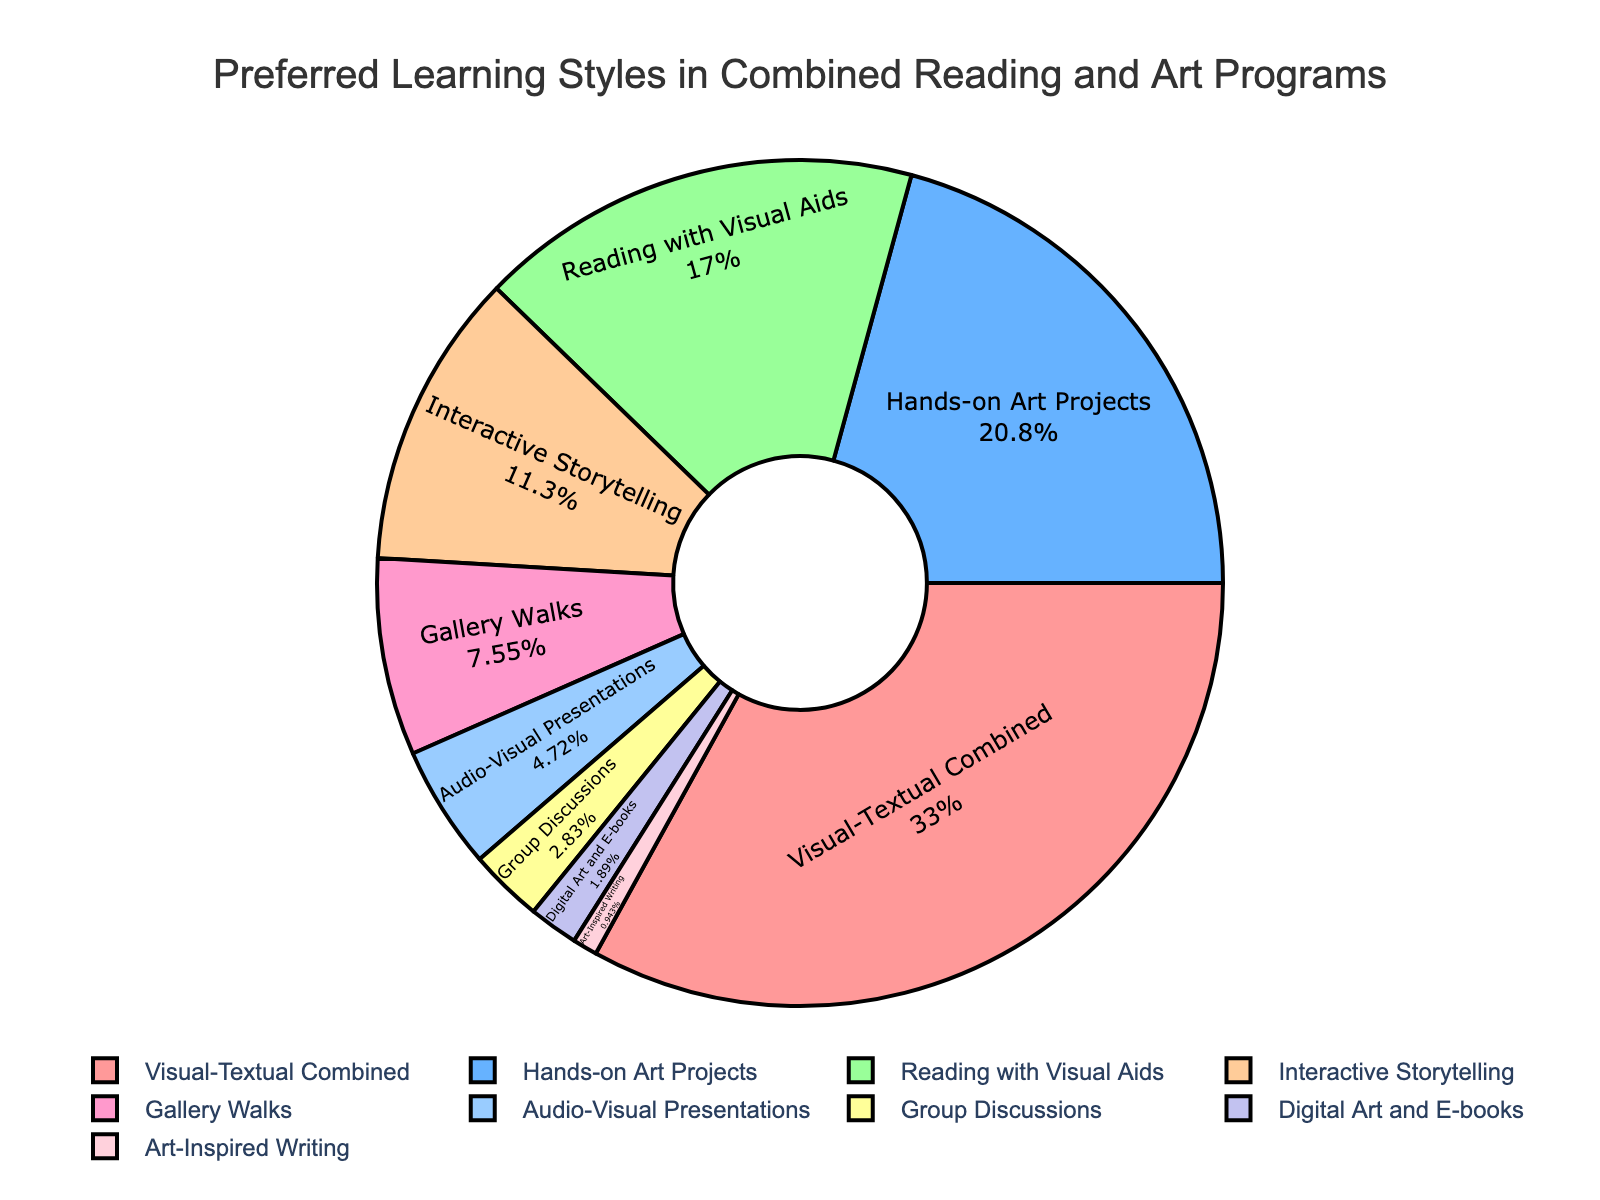Which learning style is preferred by the largest percentage of students? The figure shows the percentage distribution of various learning styles among students. The largest segment corresponds to the "Visual-Textual Combined" category with a percentage of 35%.
Answer: Visual-Textual Combined Which two learning styles are least preferred by students? By looking at the smaller segments in the pie chart, we see that "Art-Inspired Writing" and "Digital Art and E-books" have the smallest percentages, 1% and 2% respectively.
Answer: Art-Inspired Writing and Digital Art and E-books How much more preferred is "Hands-on Art Projects" compared to "Gallery Walks"? "Hands-on Art Projects" has 22% while "Gallery Walks" has 8%. Subtracting these values (22% - 8%) gives 14%.
Answer: 14% What is the combined percentage of "Reading with Visual Aids" and "Interactive Storytelling"? "Reading with Visual Aids" accounts for 18%, and "Interactive Storytelling" accounts for 12%. Adding these together (18% + 12%) gives 30%.
Answer: 30% If you combine the percentages of the three most preferred learning styles, what percentage of the total does it account for? The three most preferred learning styles are "Visual-Textual Combined" (35%), "Hands-on Art Projects" (22%), and "Reading with Visual Aids" (18%). Adding these (35% + 22% + 18%) gives 75%.
Answer: 75% Which segment is displayed using the blue color in the figure? By referring to the visual attributes in the pie chart, the blue-colored segment corresponds to "Hands-on Art Projects".
Answer: Hands-on Art Projects Compare the percentages of "Interactive Storytelling" and "Group Discussions". Which one is higher and by how much? "Interactive Storytelling" accounts for 12% and "Group Discussions" accounts for 3%. Subtracting these (12% - 3%) gives 9%.
Answer: Interactive Storytelling, 9% 